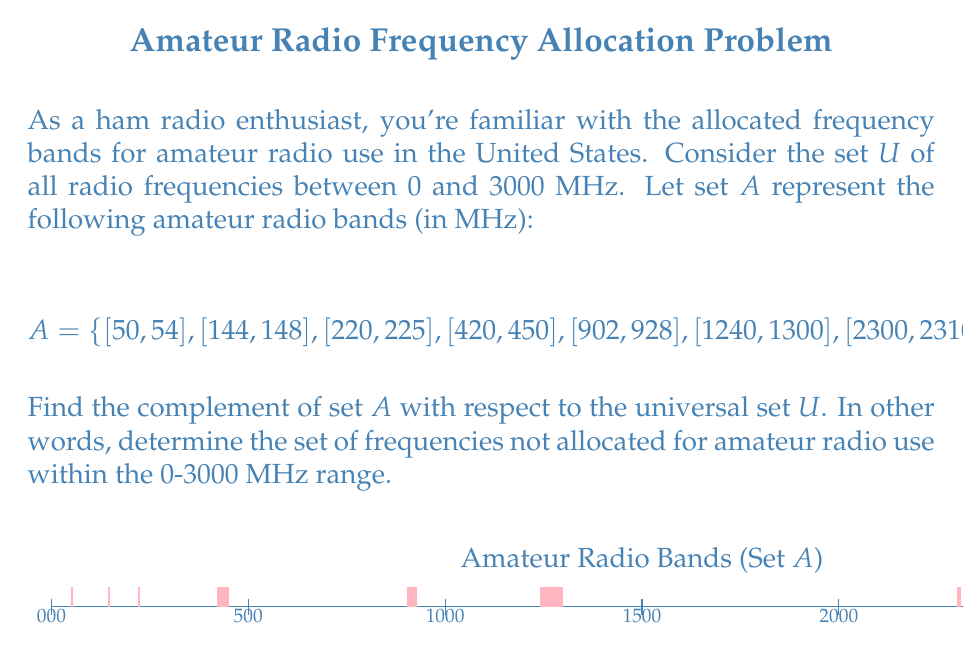Show me your answer to this math problem. To find the complement of set $A$, we need to identify all frequencies in $U$ that are not in $A$. Let's approach this step-by-step:

1) The universal set $U$ is defined as $U = [0, 3000]$ MHz.

2) Set $A$ consists of 8 intervals. To find its complement, we need to find the gaps between these intervals and the ranges before the first interval and after the last interval.

3) Let's call the complement $A^c$. We can express $A^c$ as a union of intervals:

   $A^c = [0, 50) \cup (54, 144) \cup (148, 220) \cup (225, 420) \cup (450, 902) \cup (928, 1240) \cup (1300, 2300) \cup (2310, 2390) \cup (2450, 3000]$

4) To verify:
   - The first interval $[0, 50)$ covers all frequencies from 0 up to (but not including) 50 MHz.
   - Each subsequent interval covers the gap between two consecutive amateur radio bands.
   - The last interval $(2450, 3000]$ covers all frequencies from just above 2450 MHz up to and including 3000 MHz.

5) This set $A^c$ represents all frequencies in the 0-3000 MHz range that are not allocated for amateur radio use.
Answer: $A^c = [0, 50) \cup (54, 144) \cup (148, 220) \cup (225, 420) \cup (450, 902) \cup (928, 1240) \cup (1300, 2300) \cup (2310, 2390) \cup (2450, 3000]$ 